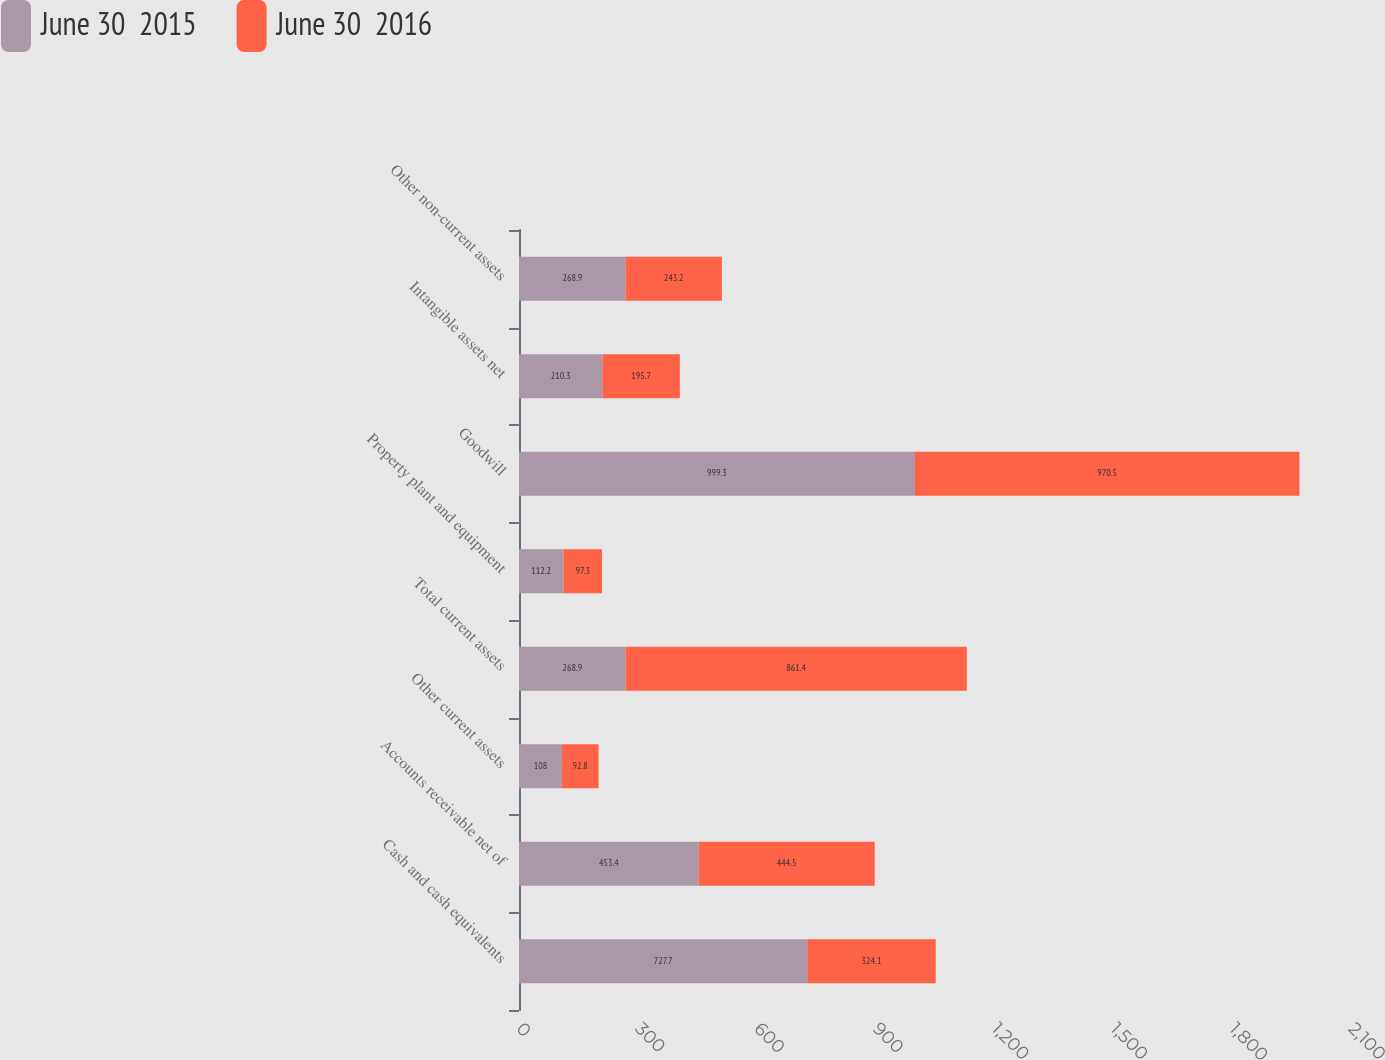Convert chart to OTSL. <chart><loc_0><loc_0><loc_500><loc_500><stacked_bar_chart><ecel><fcel>Cash and cash equivalents<fcel>Accounts receivable net of<fcel>Other current assets<fcel>Total current assets<fcel>Property plant and equipment<fcel>Goodwill<fcel>Intangible assets net<fcel>Other non-current assets<nl><fcel>June 30  2015<fcel>727.7<fcel>453.4<fcel>108<fcel>268.9<fcel>112.2<fcel>999.3<fcel>210.3<fcel>268.9<nl><fcel>June 30  2016<fcel>324.1<fcel>444.5<fcel>92.8<fcel>861.4<fcel>97.3<fcel>970.5<fcel>195.7<fcel>243.2<nl></chart> 